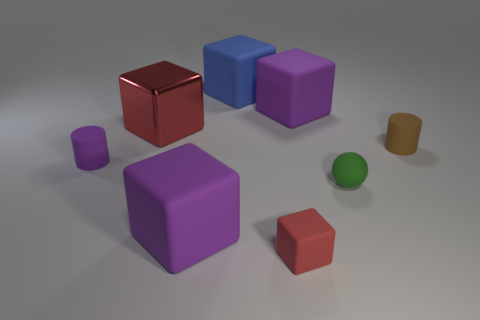Add 2 small red things. How many objects exist? 10 Subtract all purple blocks. How many blocks are left? 3 Subtract all purple cylinders. How many red blocks are left? 2 Subtract all purple cubes. How many cubes are left? 3 Subtract 1 balls. How many balls are left? 0 Subtract all spheres. How many objects are left? 7 Subtract 1 purple cylinders. How many objects are left? 7 Subtract all red blocks. Subtract all purple balls. How many blocks are left? 3 Subtract all small brown cylinders. Subtract all tiny green rubber spheres. How many objects are left? 6 Add 2 large blue matte cubes. How many large blue matte cubes are left? 3 